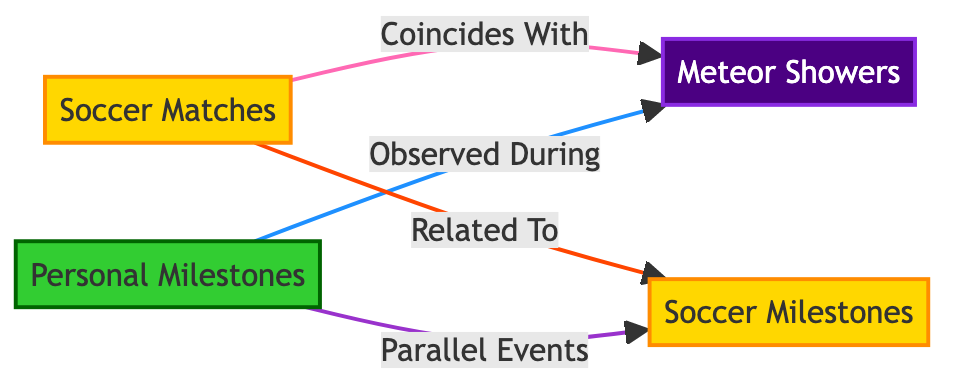What are the types of events shown in the diagram? The diagram categorizes events into soccer matches, meteor showers, personal milestones, and soccer milestones. This is determined by examining the labels on the nodes.
Answer: soccer matches, meteor showers, personal milestones, soccer milestones How many types of relationships are present in the diagram? There are four unique relationships shown in the diagram: "Coincides With," "Observed During," "Related To," and "Parallel Events." Counting these links gives us the total.
Answer: four What color represents meteor showers? The meteor showers node is filled with a color code #4B0082, which indicates the color assigned to it. Referencing the node's class color confirms this information.
Answer: #4B0082 Which events are related to soccer milestones? The diagram indicates that soccer matches and personal milestones are related to soccer milestones, as both nodes connect to the soccer milestones node through specific relationships.
Answer: soccer matches, personal milestones How do personal milestones relate to meteor showers? Personal milestones are connected to meteor showers by the relationship "Observed During." Tracing the direct link from the personal milestones node to the meteor showers node illustrates this connection.
Answer: Observed During What does the link color between soccer matches and meteor showers signify? The link from soccer matches to meteor showers is colored #FF69B4, which is designated to represent the relationship "Coincides With," as indicated in the specific link styles.
Answer: Coincides With How many personal milestones are there in the diagram? The diagram only displays one node labeled "Personal Milestones." Since it depicts a single entity, we can conclude the total count is one.
Answer: one Which node is considered astronomical in this diagram? The node labeled "Meteor Showers" is categorized as astronomical, as indicated by the class definition applied to it in the diagram.
Answer: Meteor Showers What does the class color #32CD32 denote? The color code #32CD32 represents the personal milestones node, as specified in the class definitions within the diagram context.
Answer: personal milestones 